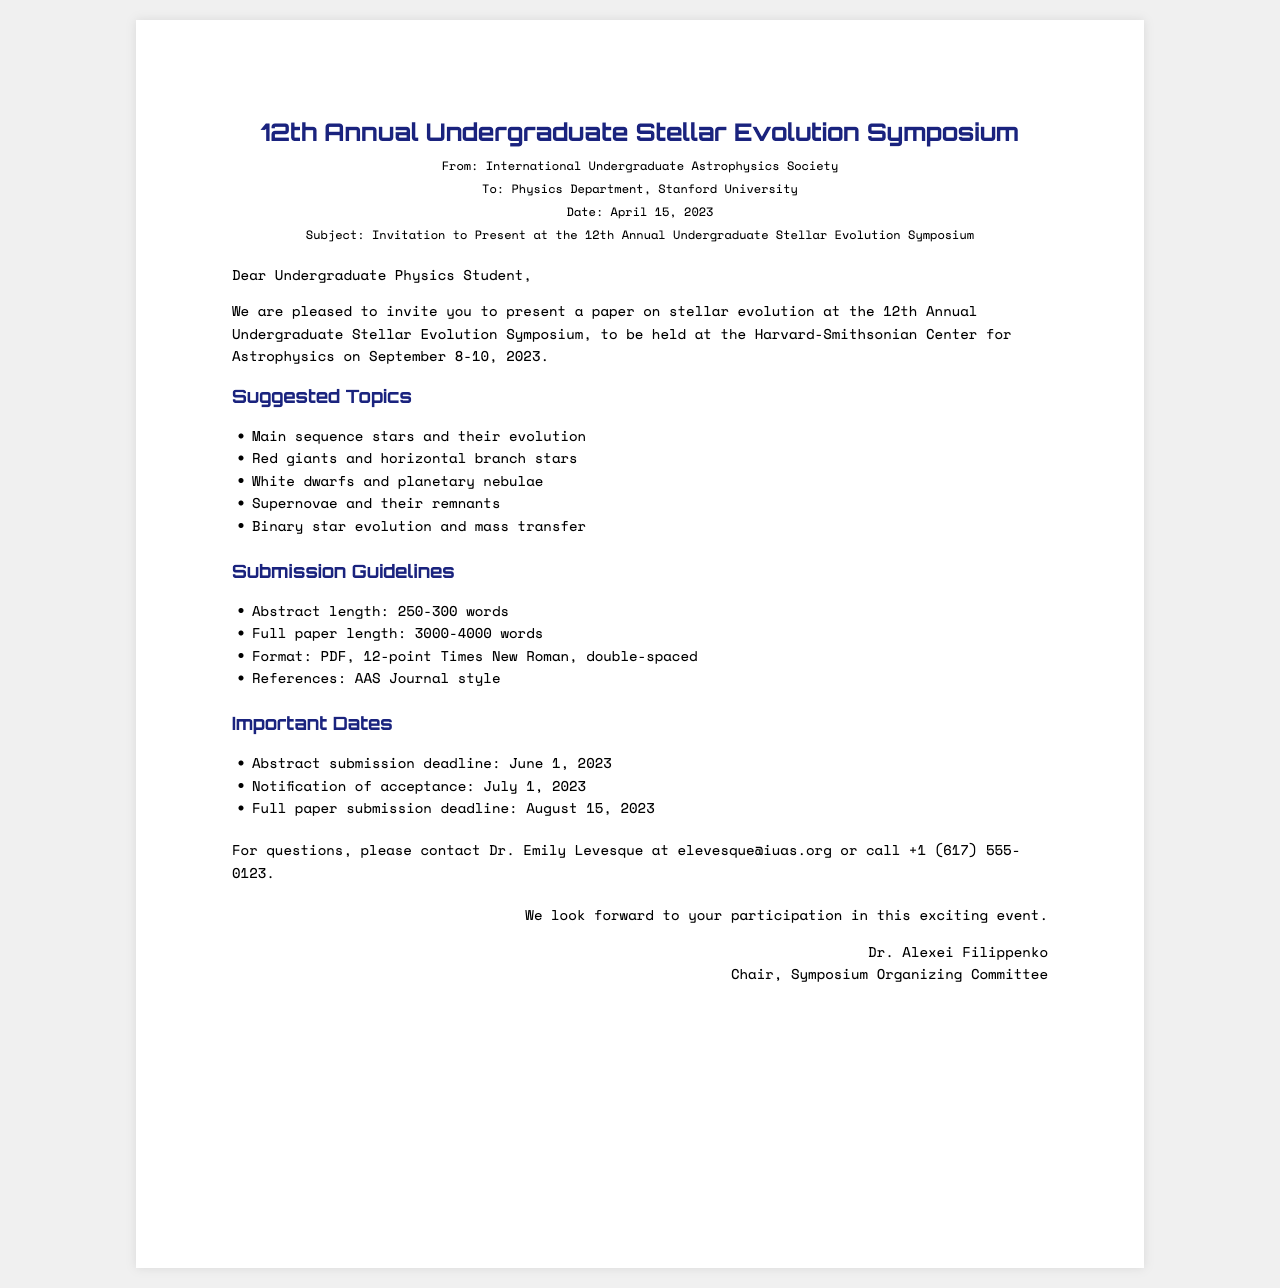What is the name of the symposium? The name of the symposium is stated clearly at the top of the document.
Answer: 12th Annual Undergraduate Stellar Evolution Symposium Who is the invitation from? The document mentions the sender at the top section.
Answer: International Undergraduate Astrophysics Society What are the suggested topics? The document lists several topics related to stellar evolution.
Answer: Main sequence stars and their evolution What is the abstract submission deadline? The deadline for abstract submission is listed in the important dates section.
Answer: June 1, 2023 What is the maximum length for the full paper? The document specifies the length limitations for the full paper in the submission guidelines section.
Answer: 3000-4000 words Who should questions be directed to? The contact person for inquiries is clearly mentioned in the document.
Answer: Dr. Emily Levesque When will notification of acceptance be sent out? The document specifies when the notification of acceptance will occur under important dates.
Answer: July 1, 2023 What format should the submissions be in? The document indicates the required format for submissions in the submission guidelines section.
Answer: PDF Where is the symposium going to be held? The location of the symposium is mentioned in the introductory paragraph.
Answer: Harvard-Smithsonian Center for Astrophysics 